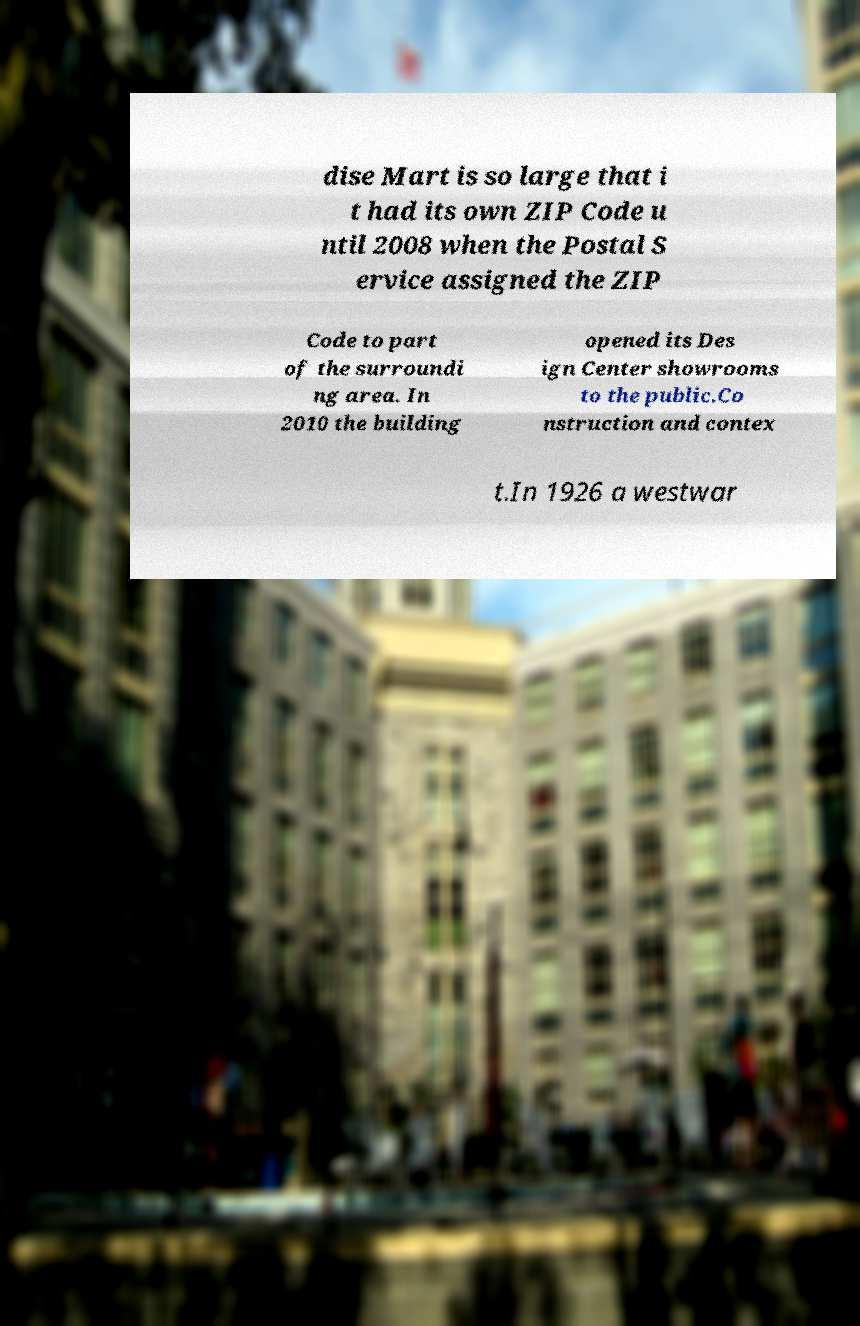Could you assist in decoding the text presented in this image and type it out clearly? dise Mart is so large that i t had its own ZIP Code u ntil 2008 when the Postal S ervice assigned the ZIP Code to part of the surroundi ng area. In 2010 the building opened its Des ign Center showrooms to the public.Co nstruction and contex t.In 1926 a westwar 